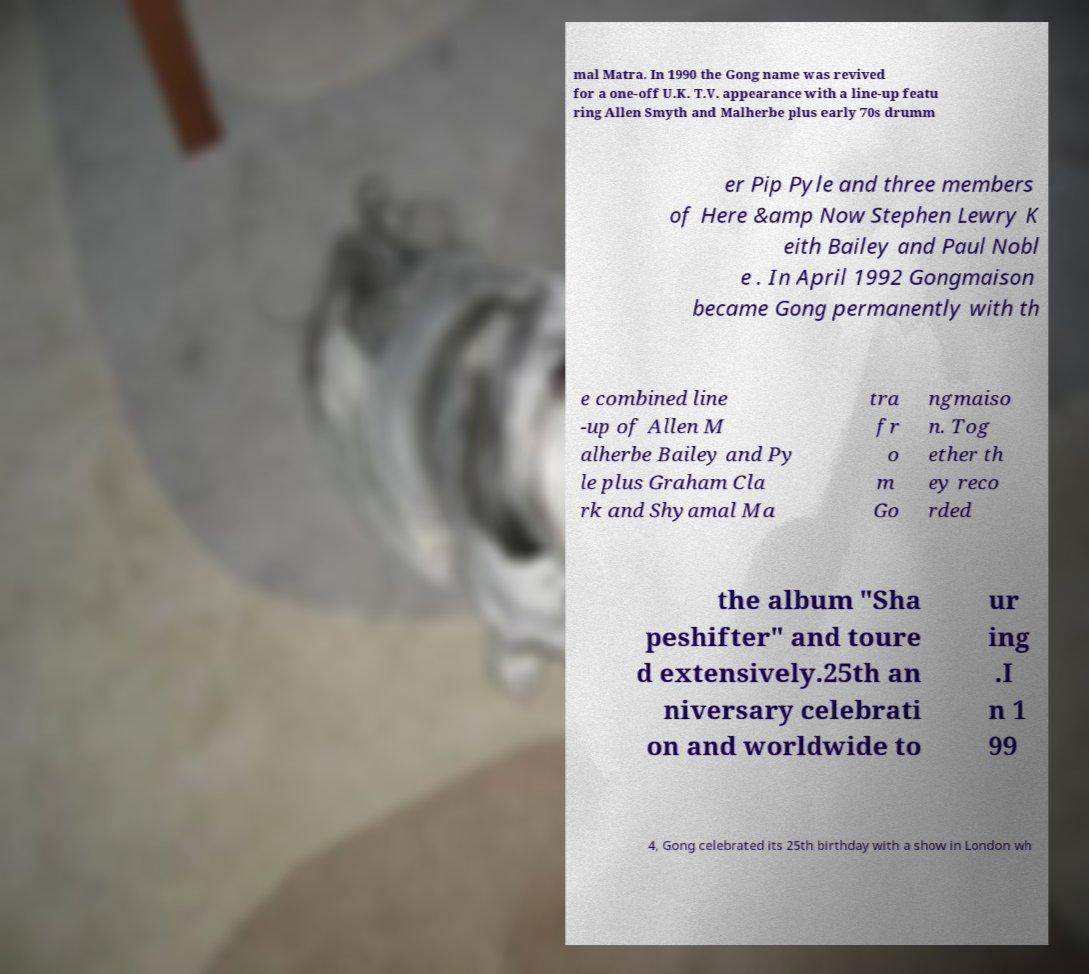Can you accurately transcribe the text from the provided image for me? mal Matra. In 1990 the Gong name was revived for a one-off U.K. T.V. appearance with a line-up featu ring Allen Smyth and Malherbe plus early 70s drumm er Pip Pyle and three members of Here &amp Now Stephen Lewry K eith Bailey and Paul Nobl e . In April 1992 Gongmaison became Gong permanently with th e combined line -up of Allen M alherbe Bailey and Py le plus Graham Cla rk and Shyamal Ma tra fr o m Go ngmaiso n. Tog ether th ey reco rded the album "Sha peshifter" and toure d extensively.25th an niversary celebrati on and worldwide to ur ing .I n 1 99 4, Gong celebrated its 25th birthday with a show in London wh 